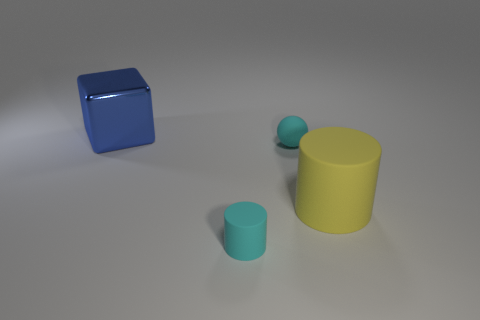Add 1 yellow rubber things. How many objects exist? 5 Subtract all spheres. How many objects are left? 3 Add 4 big metallic objects. How many big metallic objects exist? 5 Subtract 0 blue cylinders. How many objects are left? 4 Subtract all blue shiny objects. Subtract all large gray metal blocks. How many objects are left? 3 Add 2 tiny cyan spheres. How many tiny cyan spheres are left? 3 